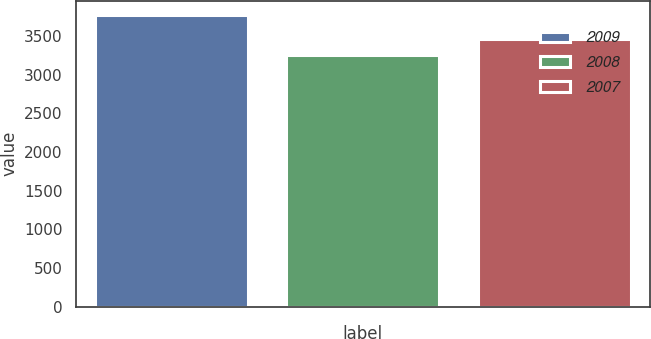Convert chart. <chart><loc_0><loc_0><loc_500><loc_500><bar_chart><fcel>2009<fcel>2008<fcel>2007<nl><fcel>3768<fcel>3260<fcel>3458<nl></chart> 